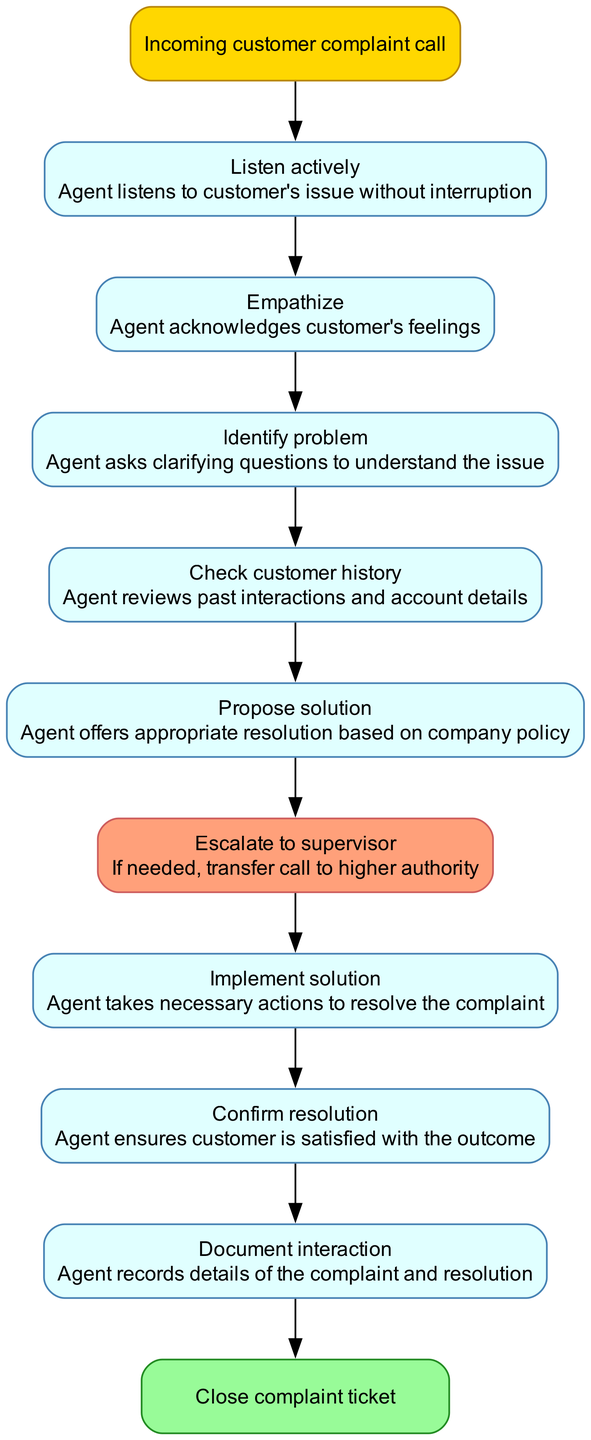What is the first step in the complaint resolution process? The first step is labeled "Listen actively," which refers to the agent listening to the customer's issue without interruption.
Answer: Listen actively How many steps are in the complaint resolution process? The diagram lists a total of 9 steps from the start to closing the ticket, including the start and end nodes.
Answer: 9 Which step involves confirming customer satisfaction? The step titled "Confirm resolution" is specifically focused on ensuring that the customer is satisfied with the outcome of the resolution.
Answer: Confirm resolution What color represents the "Escalate to supervisor" node? The node for "Escalate to supervisor" is highlighted in the color #FFA07A, which is a light salmon color in the diagram.
Answer: Light salmon What step follows "Check customer history"? The step that follows "Check customer history" is "Propose solution," in which the agent offers an appropriate resolution based on company policy.
Answer: Propose solution In which step does the agent take necessary actions to resolve the complaint? The "Implement solution" step is where the agent takes the necessary actions to effectively resolve the customer's complaint.
Answer: Implement solution What is the end point of the complaint resolution process? The end point is labeled "Close complaint ticket," signifying the conclusion of the complaint resolution process.
Answer: Close complaint ticket Which step directly follows "Empathize"? The step that directly follows "Empathize" is "Identify problem," where the agent asks clarifying questions to understand the customer's issue better.
Answer: Identify problem What does the "Document interaction" step entail? In the "Document interaction" step, the agent records the details of the customer’s complaint and how it was resolved for future reference.
Answer: Document interaction 